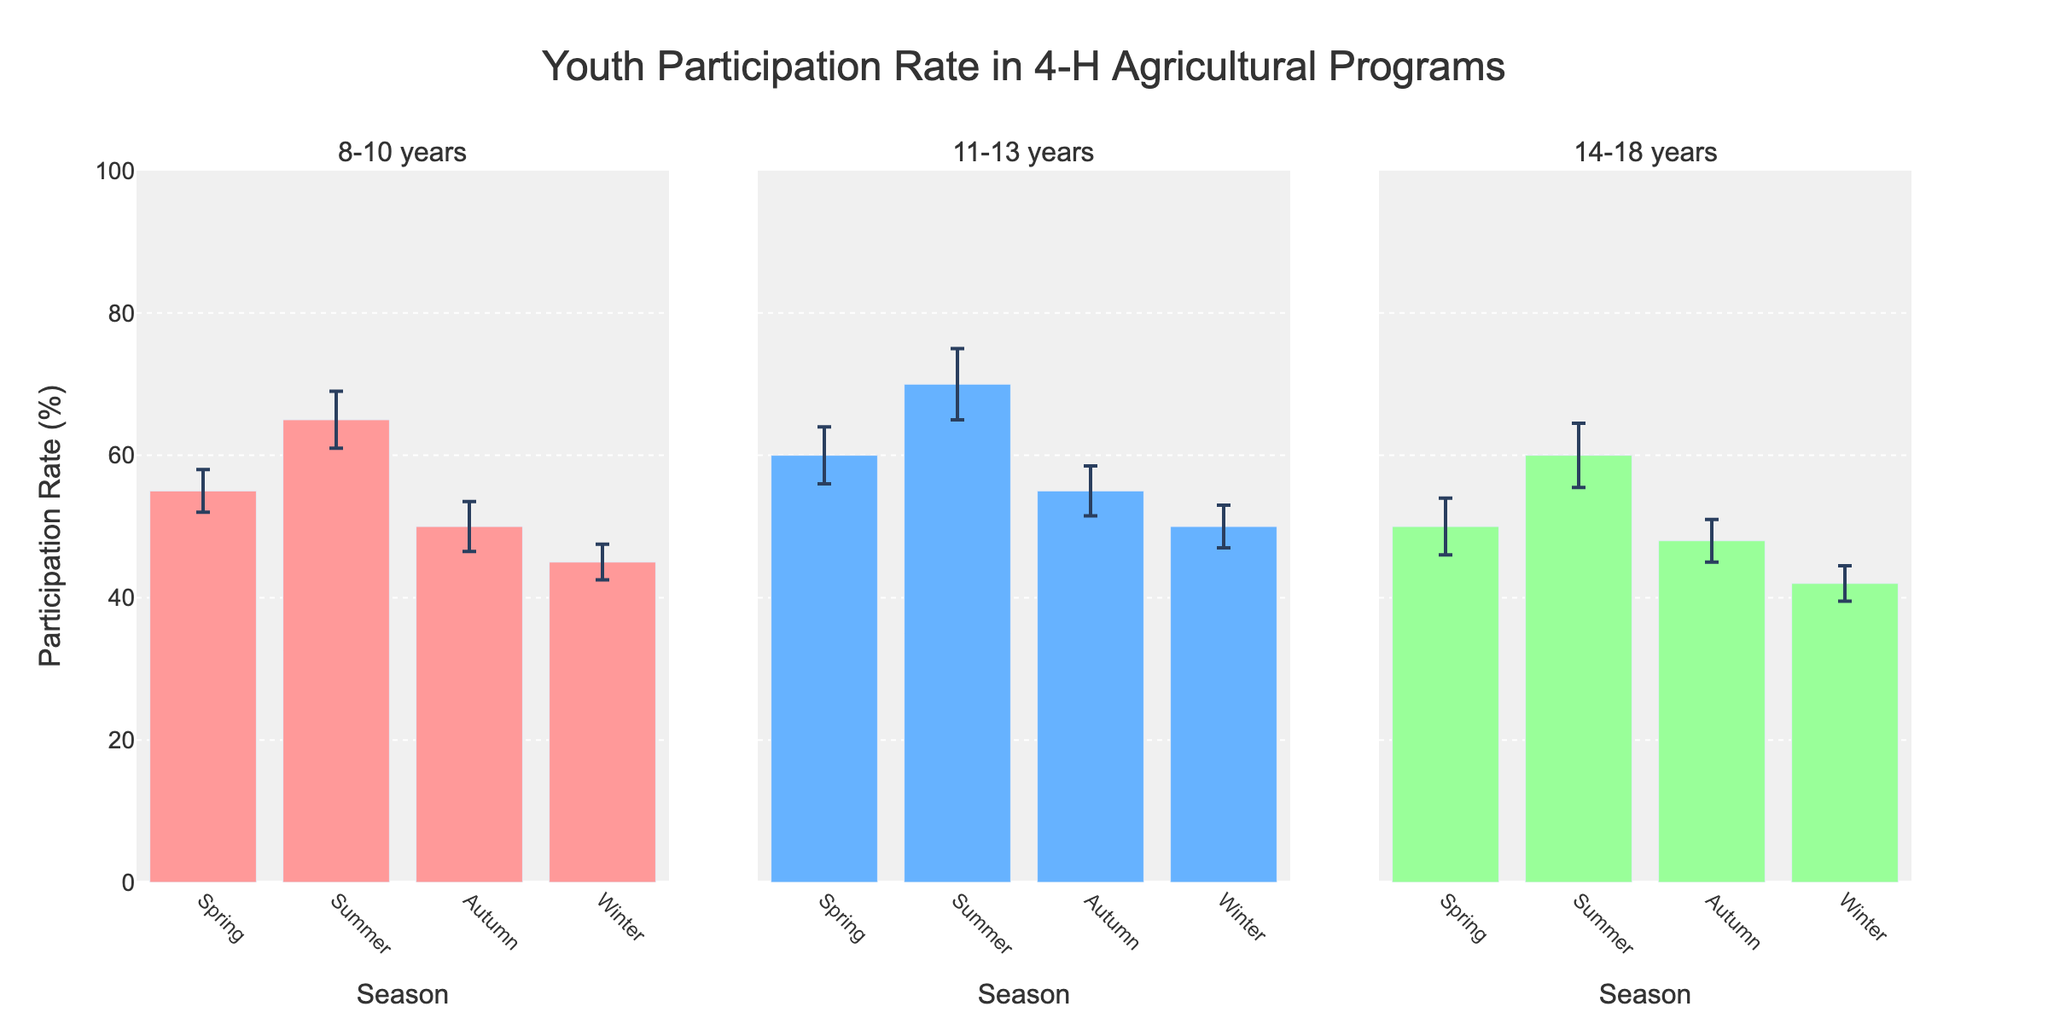What is the title of the figure? The title is located at the top of the figure and provides the main focus of the data being visualized. By reading the text in the title area, we can determine the title.
Answer: Youth Participation Rate in 4-H Agricultural Programs How many seasonal bars are there for each age group? Each subplot corresponds to a specific age group and contains four bars representing the four seasons: Spring, Summer, Autumn, and Winter.
Answer: 4 Which age group has the highest participation rate and in which season? By examining the bars and their heights in each subplot, we identify the highest bar. In the subplot for the 11-13 years age group, the Summer season shows the highest bar.
Answer: 11-13 years in Summer Which age group shows the smallest participation rate in any season? We look for the lowest bar across all subplots. In the 14-18 years age group subplot, Winter has the smallest bar.
Answer: 14-18 years in Winter What is the participation rate for the 8-10 years age group during Autumn? By focusing on the Autumn bar in the 8-10 years subplots, we locate its height or label to identify the participation rate.
Answer: 50% Which age group had the most consistent participation rates across all seasons? To determine consistency, we need to check the bars' heights and their error bars. The 14-18 years age group shows less variation in participation rates across the seasons as evidenced by similar bar heights with overlapping error bars.
Answer: 14-18 years What is the difference in participation rates between Summer and Winter for the 11-13 years age group? By identifying the heights of the bars in the Summer and Winter for the 11-13 years age group and calculating the difference: 70% (Summer) - 50% (Winter).
Answer: 20% What is the average participation rate across all seasons for the 8-10 years age group? Sum the participation rates for each season for the 8-10 years: 55 (Spring) + 65 (Summer) + 50 (Autumn) + 45 (Winter) = 215, then divide by 4.
Answer: 53.75% Which season shows the highest participation rate overall? We need to compare the highest bars in each subplot for all seasons. The Summer season has the highest individual bar (11-13 years age group with 70%).
Answer: Summer What is the overall trend in participation rates from Spring to Winter for the 14-18 years age group? By visually examining the sequence of bars from Spring to Winter in the 14-18 years subplot, we notice a downward trend.
Answer: Decreasing trend 